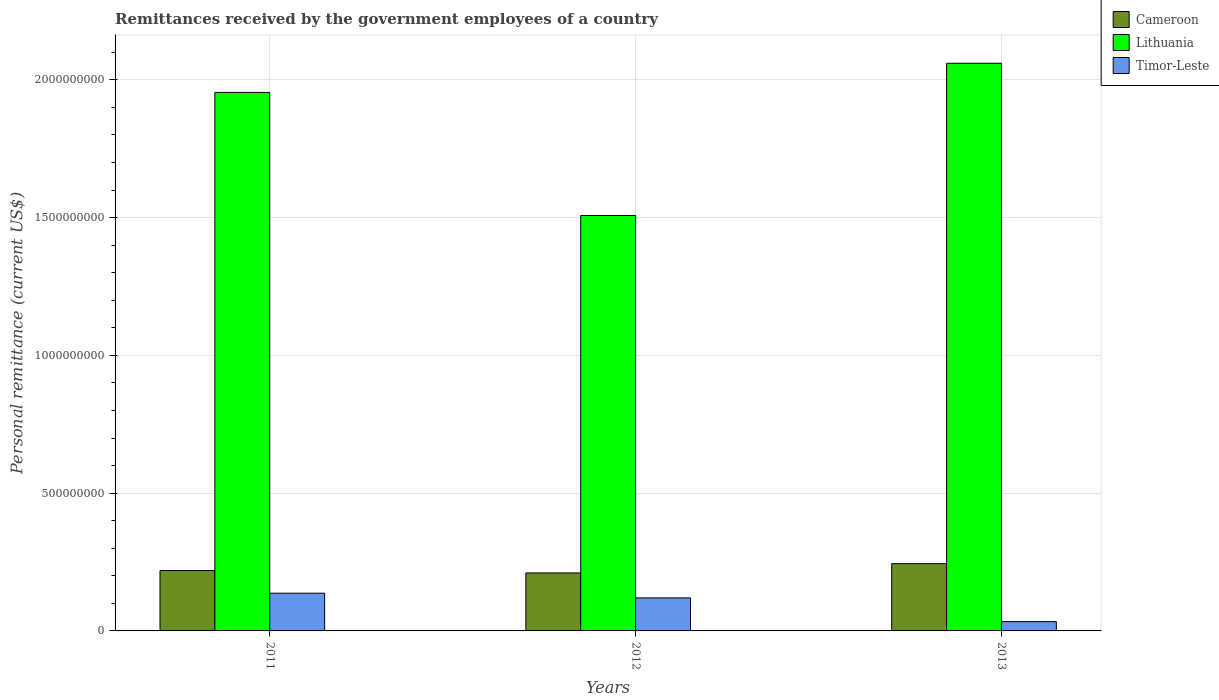Are the number of bars per tick equal to the number of legend labels?
Provide a succinct answer. Yes. How many bars are there on the 1st tick from the left?
Give a very brief answer. 3. What is the label of the 2nd group of bars from the left?
Your answer should be compact. 2012. What is the remittances received by the government employees in Cameroon in 2012?
Your answer should be compact. 2.10e+08. Across all years, what is the maximum remittances received by the government employees in Cameroon?
Ensure brevity in your answer.  2.44e+08. Across all years, what is the minimum remittances received by the government employees in Lithuania?
Offer a terse response. 1.51e+09. What is the total remittances received by the government employees in Cameroon in the graph?
Make the answer very short. 6.74e+08. What is the difference between the remittances received by the government employees in Timor-Leste in 2011 and that in 2012?
Make the answer very short. 1.70e+07. What is the difference between the remittances received by the government employees in Timor-Leste in 2011 and the remittances received by the government employees in Lithuania in 2013?
Keep it short and to the point. -1.92e+09. What is the average remittances received by the government employees in Cameroon per year?
Keep it short and to the point. 2.25e+08. In the year 2011, what is the difference between the remittances received by the government employees in Timor-Leste and remittances received by the government employees in Lithuania?
Make the answer very short. -1.82e+09. What is the ratio of the remittances received by the government employees in Cameroon in 2011 to that in 2013?
Offer a terse response. 0.9. Is the remittances received by the government employees in Cameroon in 2011 less than that in 2013?
Ensure brevity in your answer.  Yes. Is the difference between the remittances received by the government employees in Timor-Leste in 2011 and 2013 greater than the difference between the remittances received by the government employees in Lithuania in 2011 and 2013?
Provide a short and direct response. Yes. What is the difference between the highest and the second highest remittances received by the government employees in Cameroon?
Offer a very short reply. 2.48e+07. What is the difference between the highest and the lowest remittances received by the government employees in Timor-Leste?
Your answer should be compact. 1.03e+08. In how many years, is the remittances received by the government employees in Timor-Leste greater than the average remittances received by the government employees in Timor-Leste taken over all years?
Your answer should be compact. 2. What does the 3rd bar from the left in 2011 represents?
Provide a succinct answer. Timor-Leste. What does the 3rd bar from the right in 2013 represents?
Provide a short and direct response. Cameroon. Is it the case that in every year, the sum of the remittances received by the government employees in Timor-Leste and remittances received by the government employees in Lithuania is greater than the remittances received by the government employees in Cameroon?
Provide a short and direct response. Yes. How many bars are there?
Keep it short and to the point. 9. Are all the bars in the graph horizontal?
Your answer should be compact. No. What is the difference between two consecutive major ticks on the Y-axis?
Ensure brevity in your answer.  5.00e+08. Does the graph contain any zero values?
Provide a short and direct response. No. Where does the legend appear in the graph?
Offer a very short reply. Top right. How many legend labels are there?
Your answer should be compact. 3. What is the title of the graph?
Provide a succinct answer. Remittances received by the government employees of a country. What is the label or title of the Y-axis?
Offer a very short reply. Personal remittance (current US$). What is the Personal remittance (current US$) of Cameroon in 2011?
Your answer should be compact. 2.19e+08. What is the Personal remittance (current US$) in Lithuania in 2011?
Your response must be concise. 1.95e+09. What is the Personal remittance (current US$) in Timor-Leste in 2011?
Provide a succinct answer. 1.37e+08. What is the Personal remittance (current US$) of Cameroon in 2012?
Offer a very short reply. 2.10e+08. What is the Personal remittance (current US$) in Lithuania in 2012?
Your answer should be compact. 1.51e+09. What is the Personal remittance (current US$) in Timor-Leste in 2012?
Your answer should be compact. 1.20e+08. What is the Personal remittance (current US$) of Cameroon in 2013?
Keep it short and to the point. 2.44e+08. What is the Personal remittance (current US$) in Lithuania in 2013?
Offer a very short reply. 2.06e+09. What is the Personal remittance (current US$) of Timor-Leste in 2013?
Offer a terse response. 3.36e+07. Across all years, what is the maximum Personal remittance (current US$) in Cameroon?
Keep it short and to the point. 2.44e+08. Across all years, what is the maximum Personal remittance (current US$) of Lithuania?
Offer a very short reply. 2.06e+09. Across all years, what is the maximum Personal remittance (current US$) of Timor-Leste?
Ensure brevity in your answer.  1.37e+08. Across all years, what is the minimum Personal remittance (current US$) of Cameroon?
Give a very brief answer. 2.10e+08. Across all years, what is the minimum Personal remittance (current US$) in Lithuania?
Your answer should be very brief. 1.51e+09. Across all years, what is the minimum Personal remittance (current US$) in Timor-Leste?
Ensure brevity in your answer.  3.36e+07. What is the total Personal remittance (current US$) of Cameroon in the graph?
Make the answer very short. 6.74e+08. What is the total Personal remittance (current US$) in Lithuania in the graph?
Provide a short and direct response. 5.52e+09. What is the total Personal remittance (current US$) in Timor-Leste in the graph?
Your answer should be very brief. 2.90e+08. What is the difference between the Personal remittance (current US$) of Cameroon in 2011 and that in 2012?
Offer a very short reply. 8.84e+06. What is the difference between the Personal remittance (current US$) of Lithuania in 2011 and that in 2012?
Your answer should be compact. 4.47e+08. What is the difference between the Personal remittance (current US$) of Timor-Leste in 2011 and that in 2012?
Give a very brief answer. 1.70e+07. What is the difference between the Personal remittance (current US$) of Cameroon in 2011 and that in 2013?
Offer a very short reply. -2.48e+07. What is the difference between the Personal remittance (current US$) in Lithuania in 2011 and that in 2013?
Offer a terse response. -1.06e+08. What is the difference between the Personal remittance (current US$) of Timor-Leste in 2011 and that in 2013?
Ensure brevity in your answer.  1.03e+08. What is the difference between the Personal remittance (current US$) of Cameroon in 2012 and that in 2013?
Your response must be concise. -3.36e+07. What is the difference between the Personal remittance (current US$) in Lithuania in 2012 and that in 2013?
Give a very brief answer. -5.52e+08. What is the difference between the Personal remittance (current US$) in Timor-Leste in 2012 and that in 2013?
Make the answer very short. 8.62e+07. What is the difference between the Personal remittance (current US$) in Cameroon in 2011 and the Personal remittance (current US$) in Lithuania in 2012?
Keep it short and to the point. -1.29e+09. What is the difference between the Personal remittance (current US$) of Cameroon in 2011 and the Personal remittance (current US$) of Timor-Leste in 2012?
Ensure brevity in your answer.  9.94e+07. What is the difference between the Personal remittance (current US$) in Lithuania in 2011 and the Personal remittance (current US$) in Timor-Leste in 2012?
Provide a succinct answer. 1.83e+09. What is the difference between the Personal remittance (current US$) of Cameroon in 2011 and the Personal remittance (current US$) of Lithuania in 2013?
Your answer should be very brief. -1.84e+09. What is the difference between the Personal remittance (current US$) in Cameroon in 2011 and the Personal remittance (current US$) in Timor-Leste in 2013?
Your answer should be compact. 1.86e+08. What is the difference between the Personal remittance (current US$) in Lithuania in 2011 and the Personal remittance (current US$) in Timor-Leste in 2013?
Ensure brevity in your answer.  1.92e+09. What is the difference between the Personal remittance (current US$) of Cameroon in 2012 and the Personal remittance (current US$) of Lithuania in 2013?
Give a very brief answer. -1.85e+09. What is the difference between the Personal remittance (current US$) in Cameroon in 2012 and the Personal remittance (current US$) in Timor-Leste in 2013?
Your response must be concise. 1.77e+08. What is the difference between the Personal remittance (current US$) in Lithuania in 2012 and the Personal remittance (current US$) in Timor-Leste in 2013?
Ensure brevity in your answer.  1.47e+09. What is the average Personal remittance (current US$) of Cameroon per year?
Your answer should be compact. 2.25e+08. What is the average Personal remittance (current US$) of Lithuania per year?
Offer a very short reply. 1.84e+09. What is the average Personal remittance (current US$) of Timor-Leste per year?
Give a very brief answer. 9.68e+07. In the year 2011, what is the difference between the Personal remittance (current US$) of Cameroon and Personal remittance (current US$) of Lithuania?
Ensure brevity in your answer.  -1.73e+09. In the year 2011, what is the difference between the Personal remittance (current US$) in Cameroon and Personal remittance (current US$) in Timor-Leste?
Provide a short and direct response. 8.24e+07. In the year 2011, what is the difference between the Personal remittance (current US$) in Lithuania and Personal remittance (current US$) in Timor-Leste?
Your answer should be very brief. 1.82e+09. In the year 2012, what is the difference between the Personal remittance (current US$) of Cameroon and Personal remittance (current US$) of Lithuania?
Offer a terse response. -1.30e+09. In the year 2012, what is the difference between the Personal remittance (current US$) of Cameroon and Personal remittance (current US$) of Timor-Leste?
Provide a succinct answer. 9.06e+07. In the year 2012, what is the difference between the Personal remittance (current US$) in Lithuania and Personal remittance (current US$) in Timor-Leste?
Keep it short and to the point. 1.39e+09. In the year 2013, what is the difference between the Personal remittance (current US$) in Cameroon and Personal remittance (current US$) in Lithuania?
Your answer should be compact. -1.82e+09. In the year 2013, what is the difference between the Personal remittance (current US$) in Cameroon and Personal remittance (current US$) in Timor-Leste?
Make the answer very short. 2.10e+08. In the year 2013, what is the difference between the Personal remittance (current US$) of Lithuania and Personal remittance (current US$) of Timor-Leste?
Your answer should be very brief. 2.03e+09. What is the ratio of the Personal remittance (current US$) of Cameroon in 2011 to that in 2012?
Give a very brief answer. 1.04. What is the ratio of the Personal remittance (current US$) of Lithuania in 2011 to that in 2012?
Your response must be concise. 1.3. What is the ratio of the Personal remittance (current US$) in Timor-Leste in 2011 to that in 2012?
Give a very brief answer. 1.14. What is the ratio of the Personal remittance (current US$) of Cameroon in 2011 to that in 2013?
Your response must be concise. 0.9. What is the ratio of the Personal remittance (current US$) of Lithuania in 2011 to that in 2013?
Provide a succinct answer. 0.95. What is the ratio of the Personal remittance (current US$) of Timor-Leste in 2011 to that in 2013?
Offer a terse response. 4.07. What is the ratio of the Personal remittance (current US$) in Cameroon in 2012 to that in 2013?
Offer a very short reply. 0.86. What is the ratio of the Personal remittance (current US$) of Lithuania in 2012 to that in 2013?
Provide a succinct answer. 0.73. What is the ratio of the Personal remittance (current US$) of Timor-Leste in 2012 to that in 2013?
Provide a succinct answer. 3.56. What is the difference between the highest and the second highest Personal remittance (current US$) of Cameroon?
Provide a succinct answer. 2.48e+07. What is the difference between the highest and the second highest Personal remittance (current US$) in Lithuania?
Provide a short and direct response. 1.06e+08. What is the difference between the highest and the second highest Personal remittance (current US$) of Timor-Leste?
Provide a succinct answer. 1.70e+07. What is the difference between the highest and the lowest Personal remittance (current US$) of Cameroon?
Offer a very short reply. 3.36e+07. What is the difference between the highest and the lowest Personal remittance (current US$) in Lithuania?
Offer a terse response. 5.52e+08. What is the difference between the highest and the lowest Personal remittance (current US$) in Timor-Leste?
Your answer should be compact. 1.03e+08. 